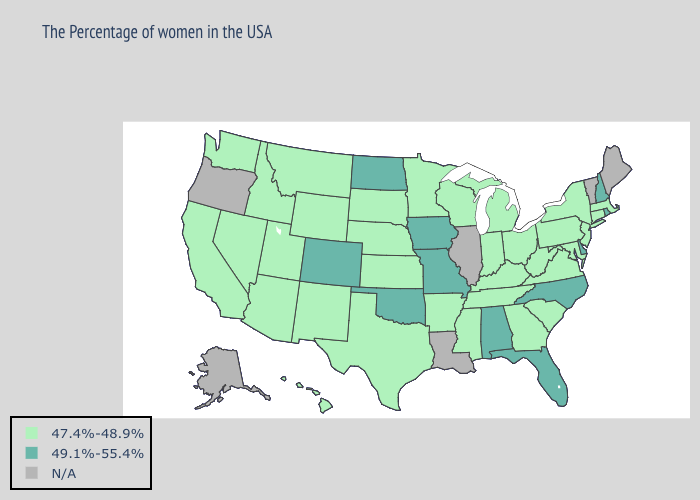What is the value of Tennessee?
Keep it brief. 47.4%-48.9%. Name the states that have a value in the range N/A?
Concise answer only. Maine, Vermont, Illinois, Louisiana, Oregon, Alaska. Name the states that have a value in the range 49.1%-55.4%?
Concise answer only. Rhode Island, New Hampshire, Delaware, North Carolina, Florida, Alabama, Missouri, Iowa, Oklahoma, North Dakota, Colorado. What is the value of Michigan?
Answer briefly. 47.4%-48.9%. Does Alabama have the lowest value in the USA?
Quick response, please. No. What is the value of Missouri?
Concise answer only. 49.1%-55.4%. What is the highest value in the USA?
Answer briefly. 49.1%-55.4%. Name the states that have a value in the range N/A?
Keep it brief. Maine, Vermont, Illinois, Louisiana, Oregon, Alaska. Does Minnesota have the highest value in the USA?
Answer briefly. No. Name the states that have a value in the range 47.4%-48.9%?
Concise answer only. Massachusetts, Connecticut, New York, New Jersey, Maryland, Pennsylvania, Virginia, South Carolina, West Virginia, Ohio, Georgia, Michigan, Kentucky, Indiana, Tennessee, Wisconsin, Mississippi, Arkansas, Minnesota, Kansas, Nebraska, Texas, South Dakota, Wyoming, New Mexico, Utah, Montana, Arizona, Idaho, Nevada, California, Washington, Hawaii. What is the lowest value in the West?
Concise answer only. 47.4%-48.9%. Does Alabama have the highest value in the South?
Concise answer only. Yes. How many symbols are there in the legend?
Be succinct. 3. What is the value of Mississippi?
Concise answer only. 47.4%-48.9%. 